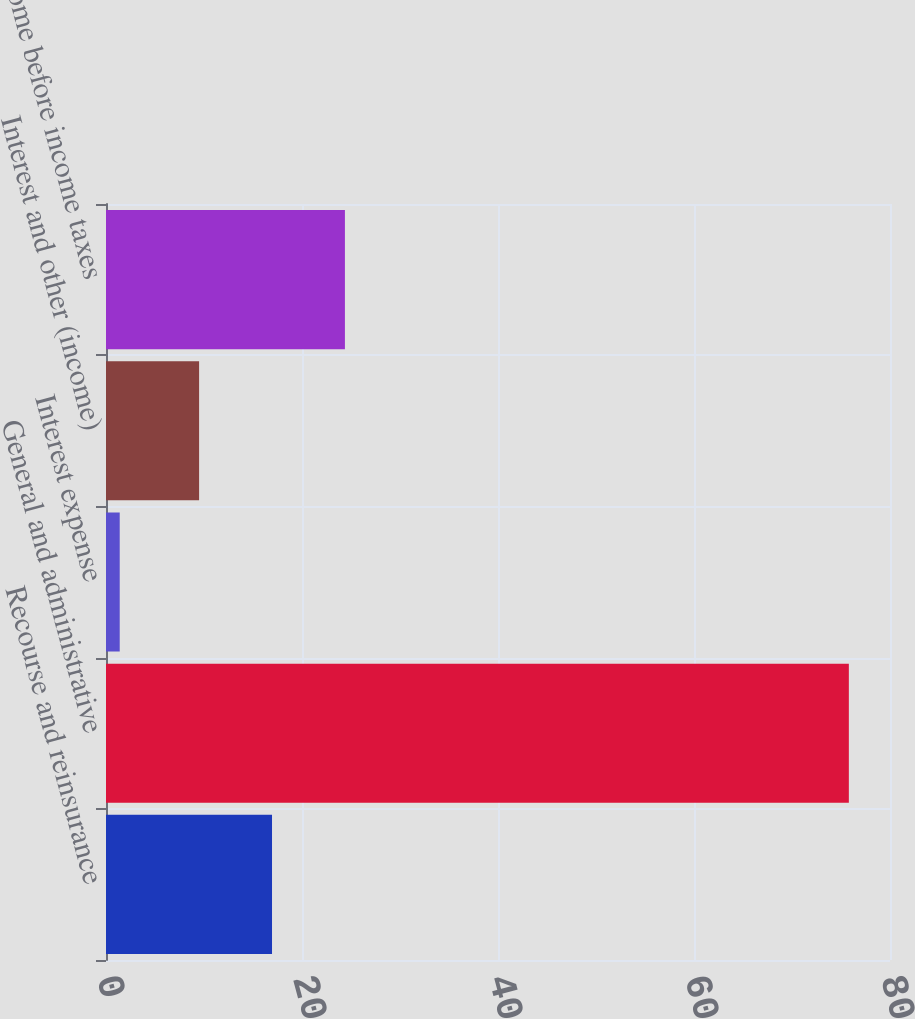Convert chart to OTSL. <chart><loc_0><loc_0><loc_500><loc_500><bar_chart><fcel>Recourse and reinsurance<fcel>General and administrative<fcel>Interest expense<fcel>Interest and other (income)<fcel>Income before income taxes<nl><fcel>16.94<fcel>75.8<fcel>1.4<fcel>9.5<fcel>24.38<nl></chart> 